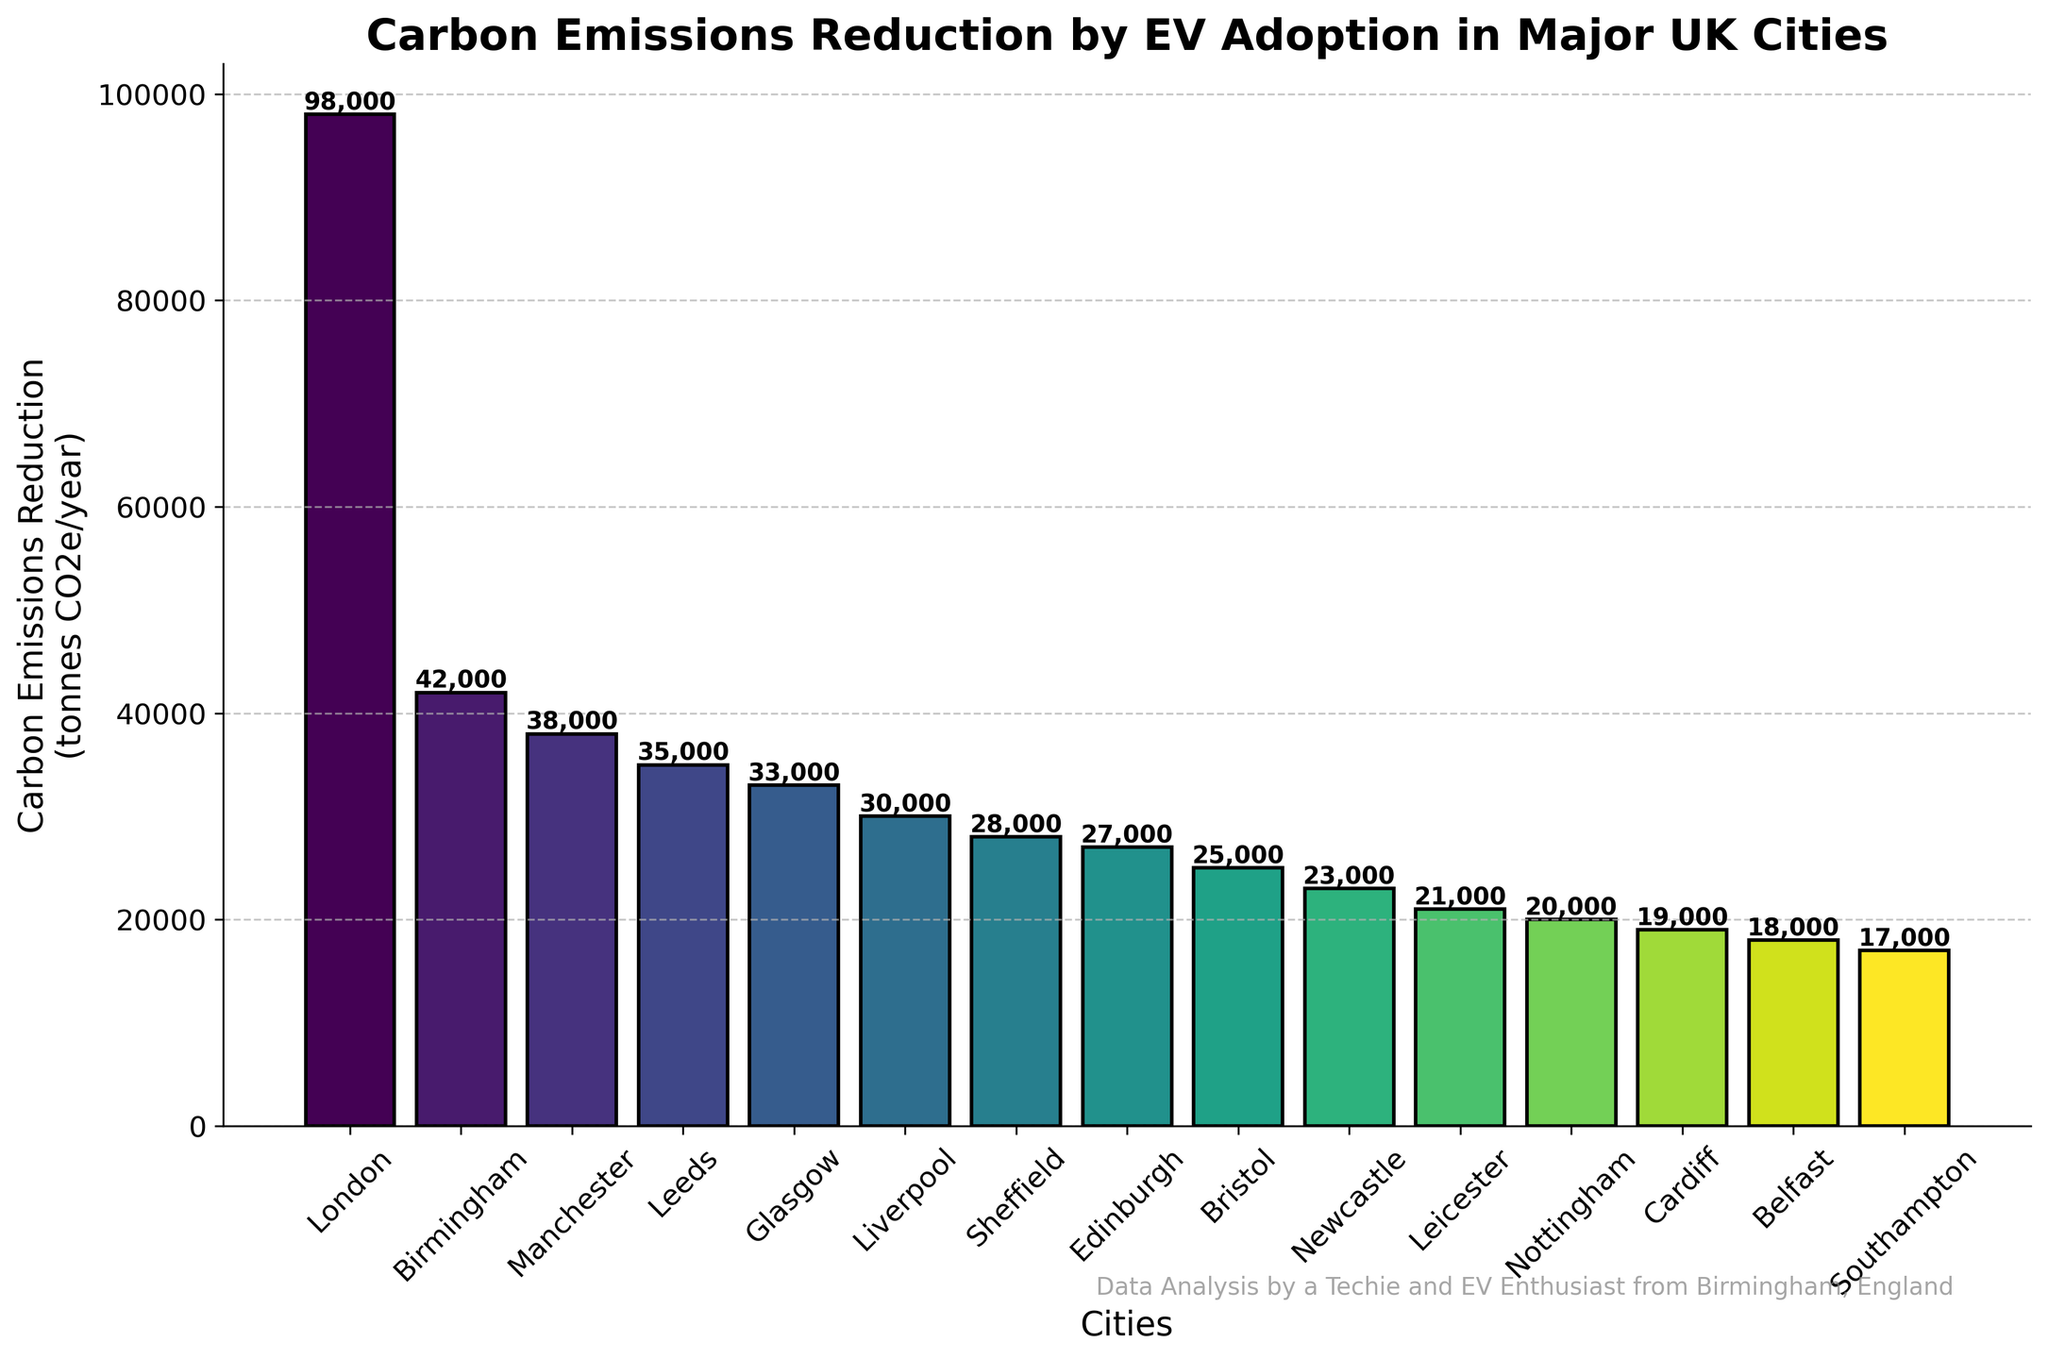Which city has the highest carbon emissions reduction? The bar chart shows the heights of the bars representing carbon emissions reduction. The tallest bar corresponds to London.
Answer: London What is the total carbon emissions reduction for Birmingham and Manchester combined? From the chart, Birmingham has a reduction of 42,000 tonnes CO2e/year and Manchester has 38,000 tonnes CO2e/year. Their combined total is 42,000 + 38,000 = 80,000 tonnes CO2e/year.
Answer: 80,000 tonnes CO2e/year How much greater is the carbon emissions reduction in London compared to Edinburgh? London has a reduction of 98,000 tonnes CO2e/year and Edinburgh has 27,000 tonnes CO2e/year. The difference is 98,000 - 27,000 = 71,000 tonnes CO2e/year.
Answer: 71,000 tonnes CO2e/year Which city has a lower carbon emissions reduction, Bristol or Nottingham? Comparing the heights of the bars, Bristol has a reduction of 25,000 tonnes CO2e/year and Nottingham has 20,000 tonnes CO2e/year. Nottingham has the lower reduction.
Answer: Nottingham How many cities have a carbon emissions reduction of 30,000 tonnes CO2e/year or higher? Observing the bars representing the carbon emissions in the chart, the cities are London, Birmingham, Manchester, Leeds, Glasgow, Liverpool, and Sheffield. There are 7 cities in total.
Answer: 7 What is the average carbon emissions reduction of the top three cities with the highest reductions? The top three cities are London (98,000), Birmingham (42,000), and Manchester (38,000). Their average reduction is calculated as (98,000 + 42,000 + 38,000) / 3 = 178,000 / 3 ≈ 59,333 tonnes CO2e/year.
Answer: 59,333 tonnes CO2e/year What is the difference in carbon emissions reduction between the cities with the lowest and the highest reductions? The city with the highest reduction is London with 98,000 tonnes CO2e/year, and the city with the lowest reduction is Southampton with 17,000 tonnes CO2e/year. The difference is 98,000 - 17,000 = 81,000 tonnes CO2e/year.
Answer: 81,000 tonnes CO2e/year Which cities have carbon emissions reductions between 20,000 and 30,000 tonnes CO2e/year? The cities with reductions in this range, according to the bar lengths, are Sheffield (28,000), Edinburgh (27,000), Bristol (25,000), Newcastle (23,000), and Leicester (21,000).
Answer: Sheffield, Edinburgh, Bristol, Newcastle, Leicester 